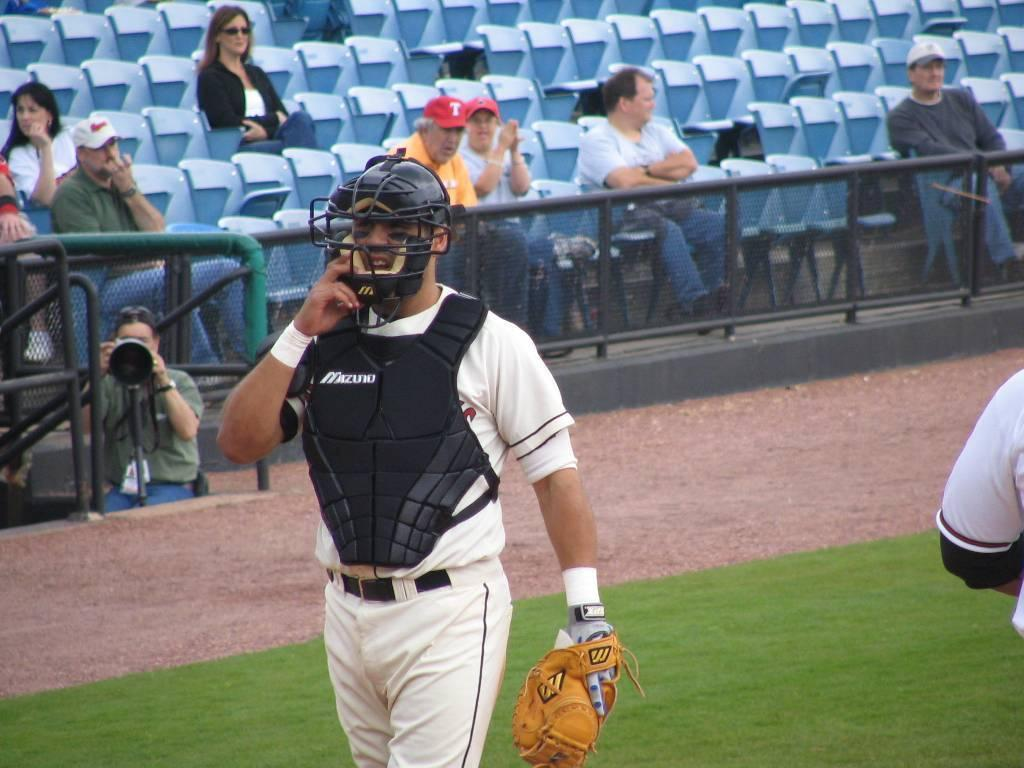<image>
Give a short and clear explanation of the subsequent image. A baseball catcher wears a protective vest, the vest reads Mizuno. 